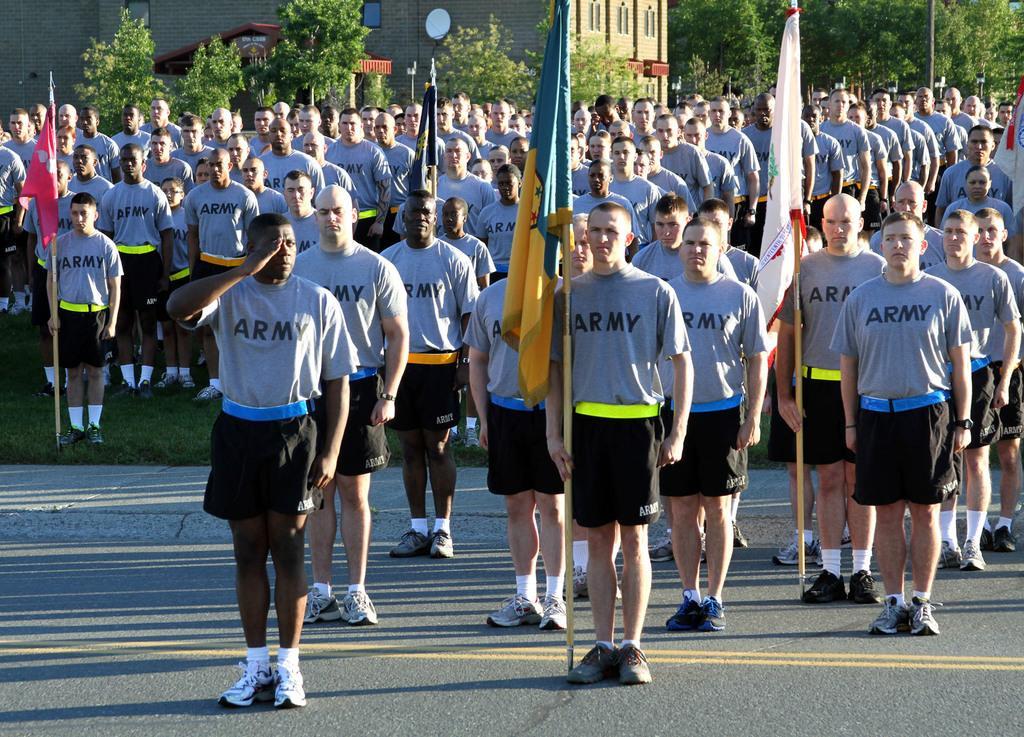Please provide a concise description of this image. In this image in front there are people holding the flags. Behind them there are a few other people standing on the surface of the grass. In the background of the image there are trees, buildings. 